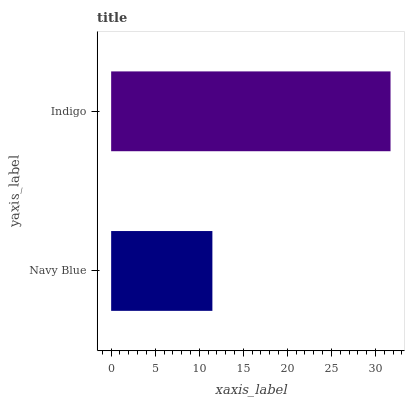Is Navy Blue the minimum?
Answer yes or no. Yes. Is Indigo the maximum?
Answer yes or no. Yes. Is Indigo the minimum?
Answer yes or no. No. Is Indigo greater than Navy Blue?
Answer yes or no. Yes. Is Navy Blue less than Indigo?
Answer yes or no. Yes. Is Navy Blue greater than Indigo?
Answer yes or no. No. Is Indigo less than Navy Blue?
Answer yes or no. No. Is Indigo the high median?
Answer yes or no. Yes. Is Navy Blue the low median?
Answer yes or no. Yes. Is Navy Blue the high median?
Answer yes or no. No. Is Indigo the low median?
Answer yes or no. No. 